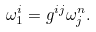Convert formula to latex. <formula><loc_0><loc_0><loc_500><loc_500>\omega _ { 1 } ^ { i } = g ^ { i j } \omega _ { j } ^ { n } .</formula> 